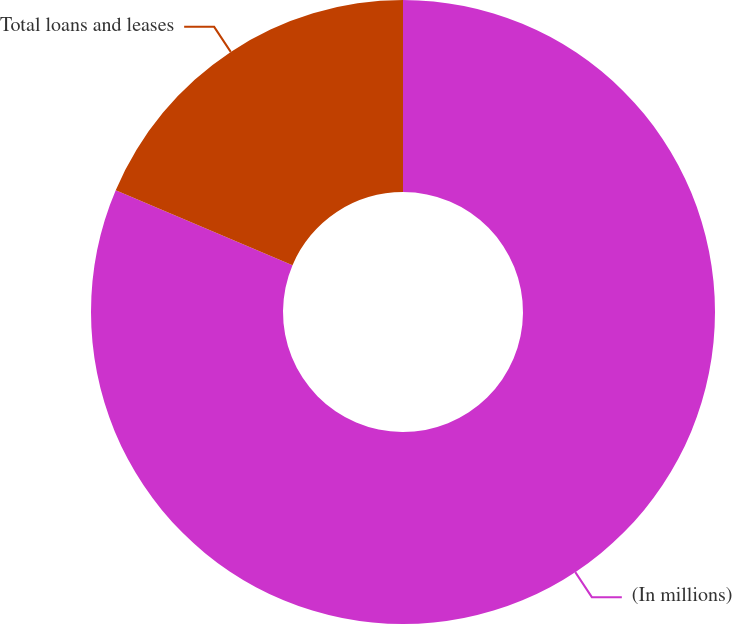<chart> <loc_0><loc_0><loc_500><loc_500><pie_chart><fcel>(In millions)<fcel>Total loans and leases<nl><fcel>81.38%<fcel>18.62%<nl></chart> 